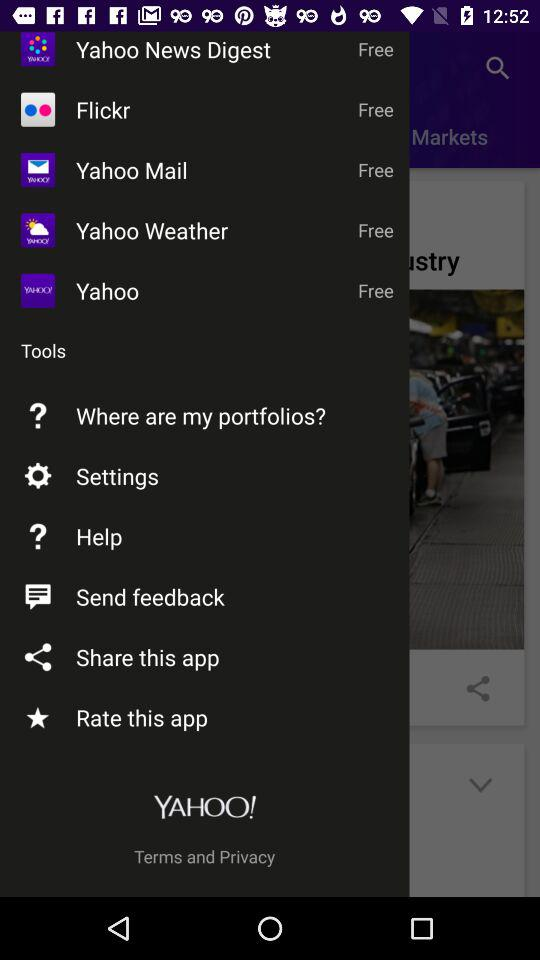How many apps are free?
Answer the question using a single word or phrase. 5 